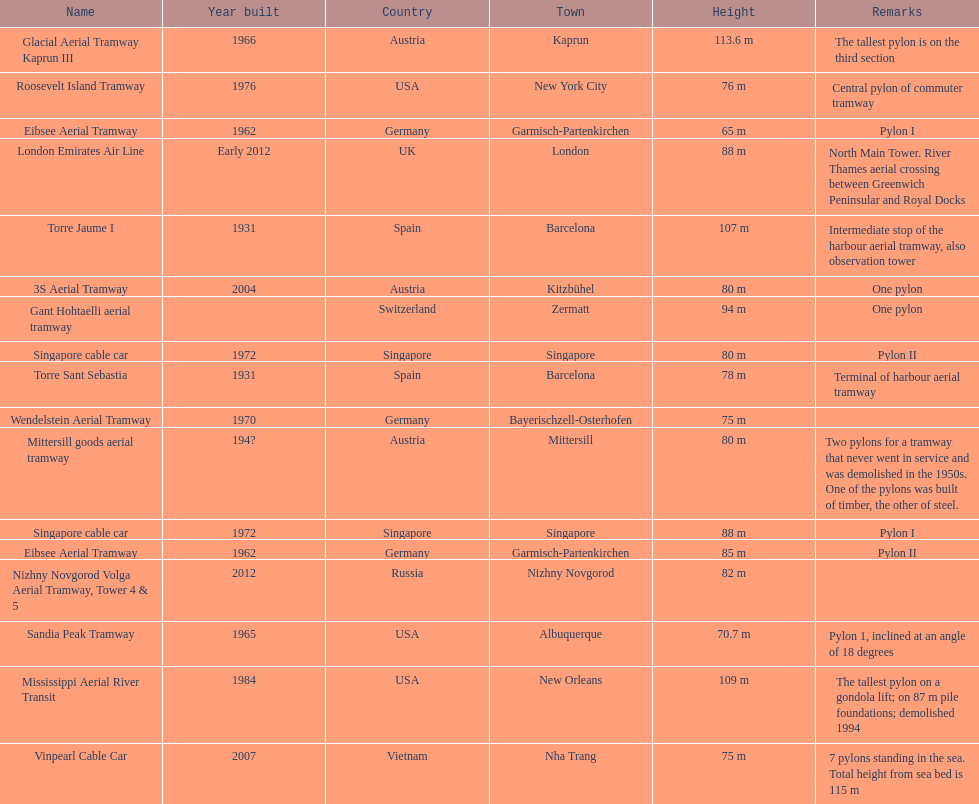How many metres is the tallest pylon? 113.6 m. 